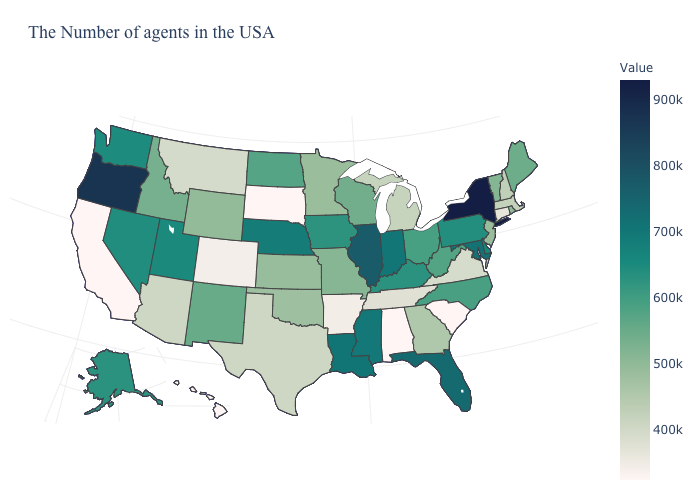Among the states that border Minnesota , which have the highest value?
Quick response, please. Iowa. Does North Carolina have a higher value than Wyoming?
Quick response, please. Yes. Does South Dakota have the lowest value in the MidWest?
Give a very brief answer. Yes. Which states hav the highest value in the MidWest?
Give a very brief answer. Illinois. Does Delaware have a lower value than New Jersey?
Concise answer only. No. 